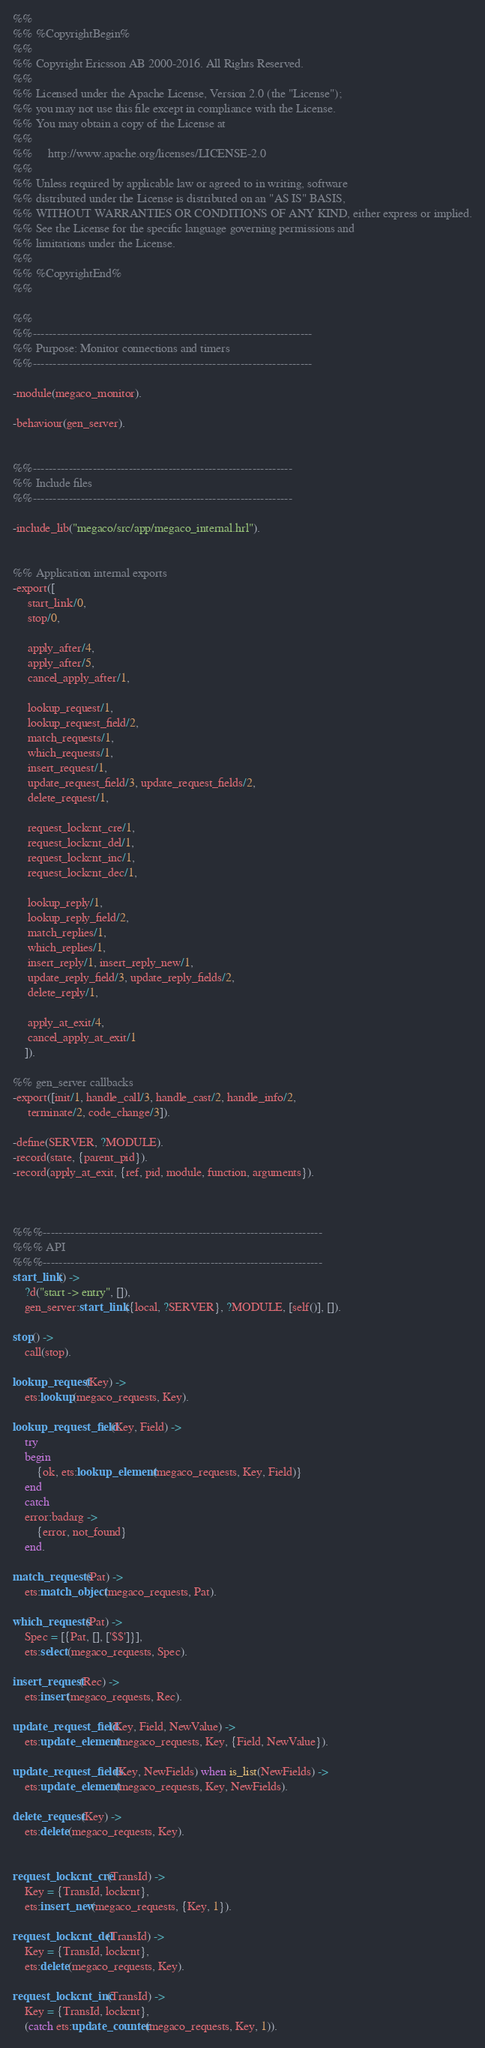<code> <loc_0><loc_0><loc_500><loc_500><_Erlang_>%%
%% %CopyrightBegin%
%%
%% Copyright Ericsson AB 2000-2016. All Rights Reserved.
%%
%% Licensed under the Apache License, Version 2.0 (the "License");
%% you may not use this file except in compliance with the License.
%% You may obtain a copy of the License at
%%
%%     http://www.apache.org/licenses/LICENSE-2.0
%%
%% Unless required by applicable law or agreed to in writing, software
%% distributed under the License is distributed on an "AS IS" BASIS,
%% WITHOUT WARRANTIES OR CONDITIONS OF ANY KIND, either express or implied.
%% See the License for the specific language governing permissions and
%% limitations under the License.
%%
%% %CopyrightEnd%
%%

%%
%%----------------------------------------------------------------------
%% Purpose: Monitor connections and timers
%%----------------------------------------------------------------------

-module(megaco_monitor).

-behaviour(gen_server).


%%-----------------------------------------------------------------
%% Include files
%%-----------------------------------------------------------------

-include_lib("megaco/src/app/megaco_internal.hrl"). 


%% Application internal exports
-export([
	 start_link/0,
	 stop/0,

	 apply_after/4,
	 apply_after/5,
	 cancel_apply_after/1,

	 lookup_request/1,
	 lookup_request_field/2,
	 match_requests/1,
	 which_requests/1,
	 insert_request/1,
	 update_request_field/3, update_request_fields/2, 
	 delete_request/1, 

	 request_lockcnt_cre/1, 
	 request_lockcnt_del/1, 
	 request_lockcnt_inc/1, 
	 request_lockcnt_dec/1, 

	 lookup_reply/1,
	 lookup_reply_field/2,
	 match_replies/1,
	 which_replies/1,
	 insert_reply/1, insert_reply_new/1,
	 update_reply_field/3, update_reply_fields/2, 
	 delete_reply/1,

	 apply_at_exit/4,
	 cancel_apply_at_exit/1
	]).

%% gen_server callbacks
-export([init/1, handle_call/3, handle_cast/2, handle_info/2,
	 terminate/2, code_change/3]).

-define(SERVER, ?MODULE).
-record(state, {parent_pid}).
-record(apply_at_exit, {ref, pid, module, function, arguments}).



%%%----------------------------------------------------------------------
%%% API
%%%----------------------------------------------------------------------
start_link() ->
    ?d("start -> entry", []),
    gen_server:start_link({local, ?SERVER}, ?MODULE, [self()], []).

stop() ->
    call(stop).

lookup_request(Key) ->
    ets:lookup(megaco_requests, Key).

lookup_request_field(Key, Field) ->
    try
	begin
	    {ok, ets:lookup_element(megaco_requests, Key, Field)}
	end
    catch 
	error:badarg ->
	    {error, not_found}
    end.

match_requests(Pat) ->
    ets:match_object(megaco_requests, Pat).

which_requests(Pat) ->
    Spec = [{Pat, [], ['$$']}],
    ets:select(megaco_requests, Spec).

insert_request(Rec) ->
    ets:insert(megaco_requests, Rec).

update_request_field(Key, Field, NewValue) ->
    ets:update_element(megaco_requests, Key, {Field, NewValue}).

update_request_fields(Key, NewFields) when is_list(NewFields) ->
    ets:update_element(megaco_requests, Key, NewFields).

delete_request(Key) ->
    ets:delete(megaco_requests, Key).


request_lockcnt_cre(TransId) ->
    Key = {TransId, lockcnt},
    ets:insert_new(megaco_requests, {Key, 1}).

request_lockcnt_del(TransId) ->
    Key = {TransId, lockcnt},
    ets:delete(megaco_requests, Key).

request_lockcnt_inc(TransId) ->
    Key = {TransId, lockcnt},
    (catch ets:update_counter(megaco_requests, Key, 1)).
</code> 